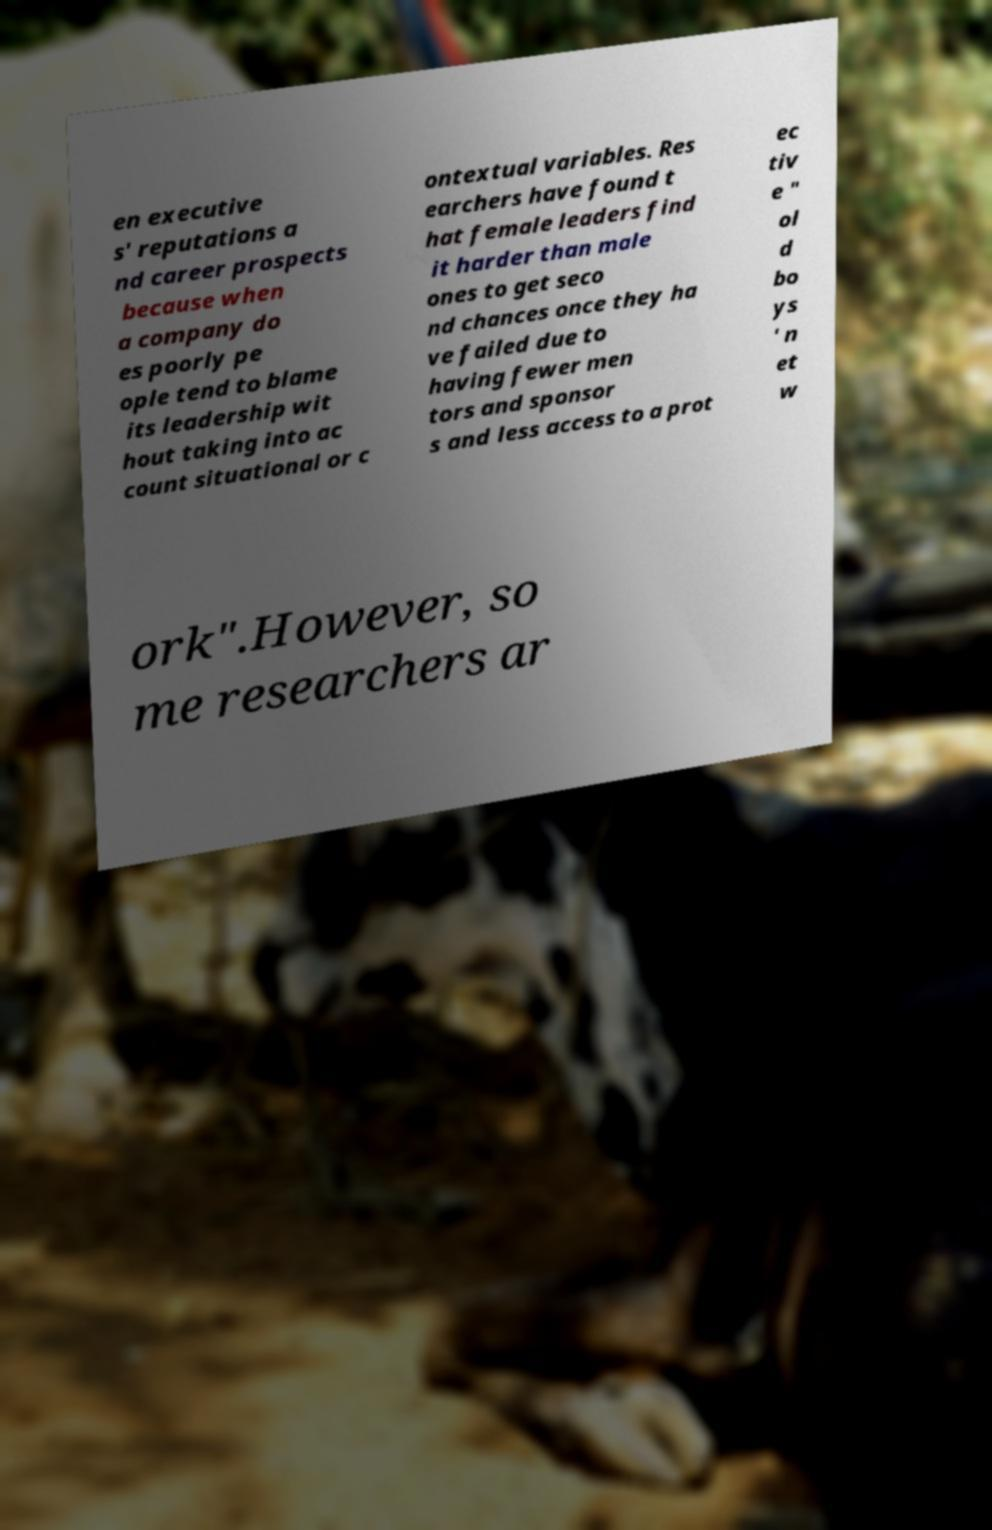I need the written content from this picture converted into text. Can you do that? en executive s' reputations a nd career prospects because when a company do es poorly pe ople tend to blame its leadership wit hout taking into ac count situational or c ontextual variables. Res earchers have found t hat female leaders find it harder than male ones to get seco nd chances once they ha ve failed due to having fewer men tors and sponsor s and less access to a prot ec tiv e " ol d bo ys ' n et w ork".However, so me researchers ar 